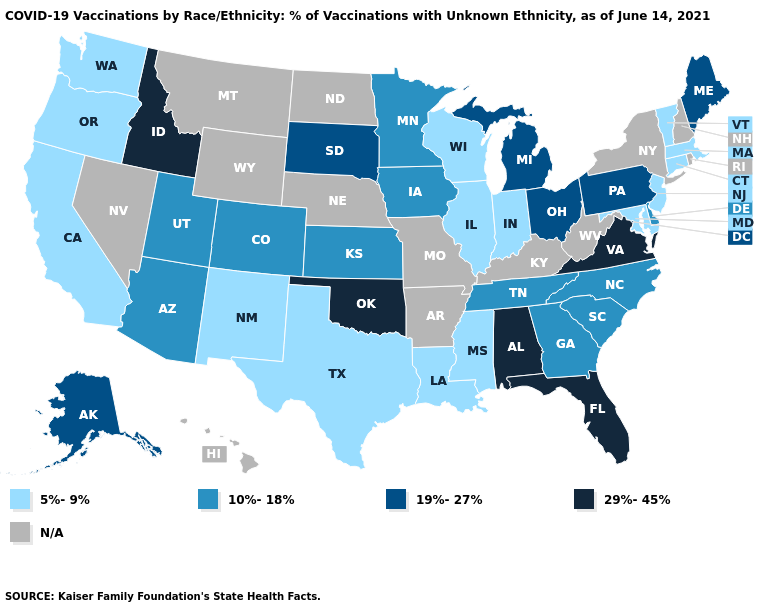Among the states that border North Dakota , which have the lowest value?
Keep it brief. Minnesota. What is the value of California?
Quick response, please. 5%-9%. What is the lowest value in the South?
Keep it brief. 5%-9%. What is the highest value in the West ?
Keep it brief. 29%-45%. What is the value of New York?
Give a very brief answer. N/A. What is the value of Nebraska?
Concise answer only. N/A. Which states have the lowest value in the MidWest?
Give a very brief answer. Illinois, Indiana, Wisconsin. How many symbols are there in the legend?
Answer briefly. 5. Which states have the lowest value in the MidWest?
Be succinct. Illinois, Indiana, Wisconsin. What is the value of Connecticut?
Quick response, please. 5%-9%. Name the states that have a value in the range N/A?
Be succinct. Arkansas, Hawaii, Kentucky, Missouri, Montana, Nebraska, Nevada, New Hampshire, New York, North Dakota, Rhode Island, West Virginia, Wyoming. What is the lowest value in the USA?
Quick response, please. 5%-9%. What is the value of Minnesota?
Answer briefly. 10%-18%. 